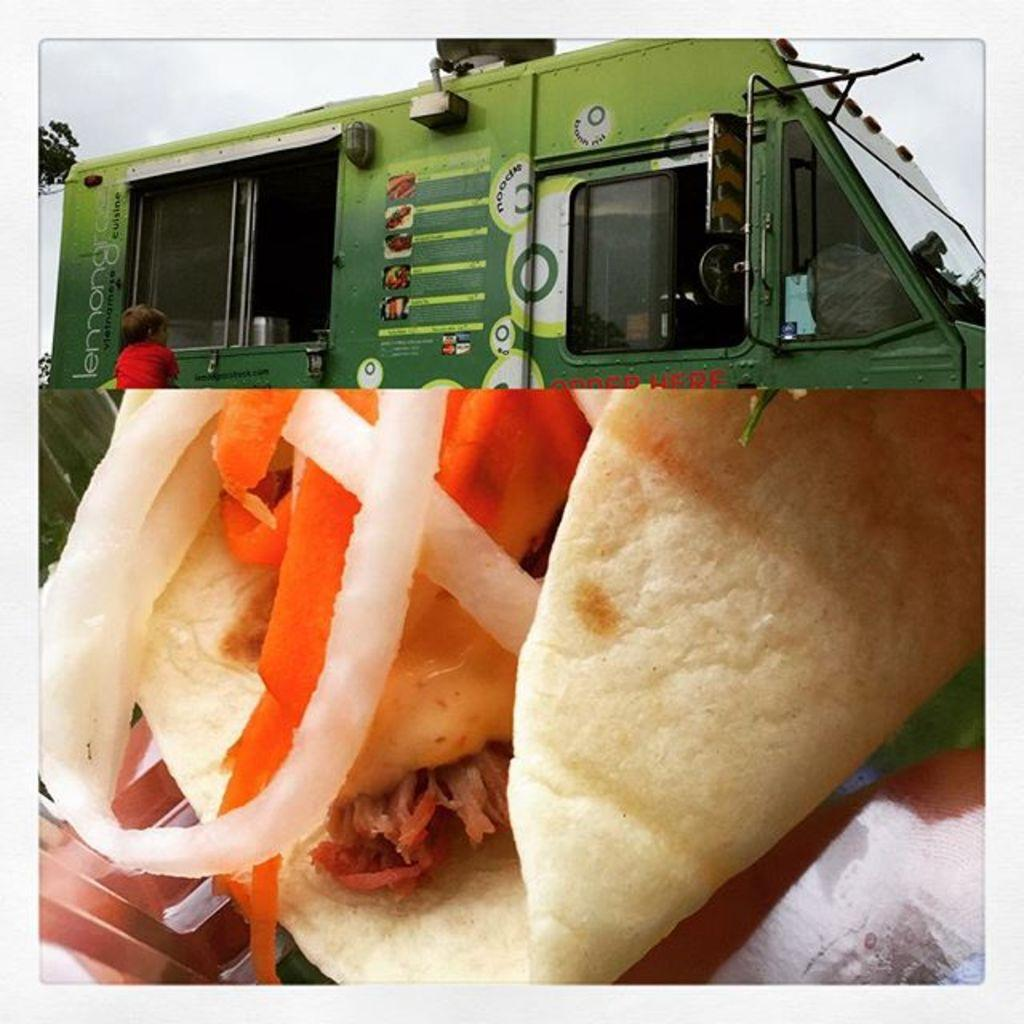What is the composition of the image? The image is a collage of two images. What can be seen at the bottom of the collage? There is a food item at the bottom of the collage. What is located at the top of the collage? There is a truck and a kid at the top of the collage. Can you see a mountain in the background of the image? There is no mountain visible in the image; it is a collage of a food item and a truck with a kid. 